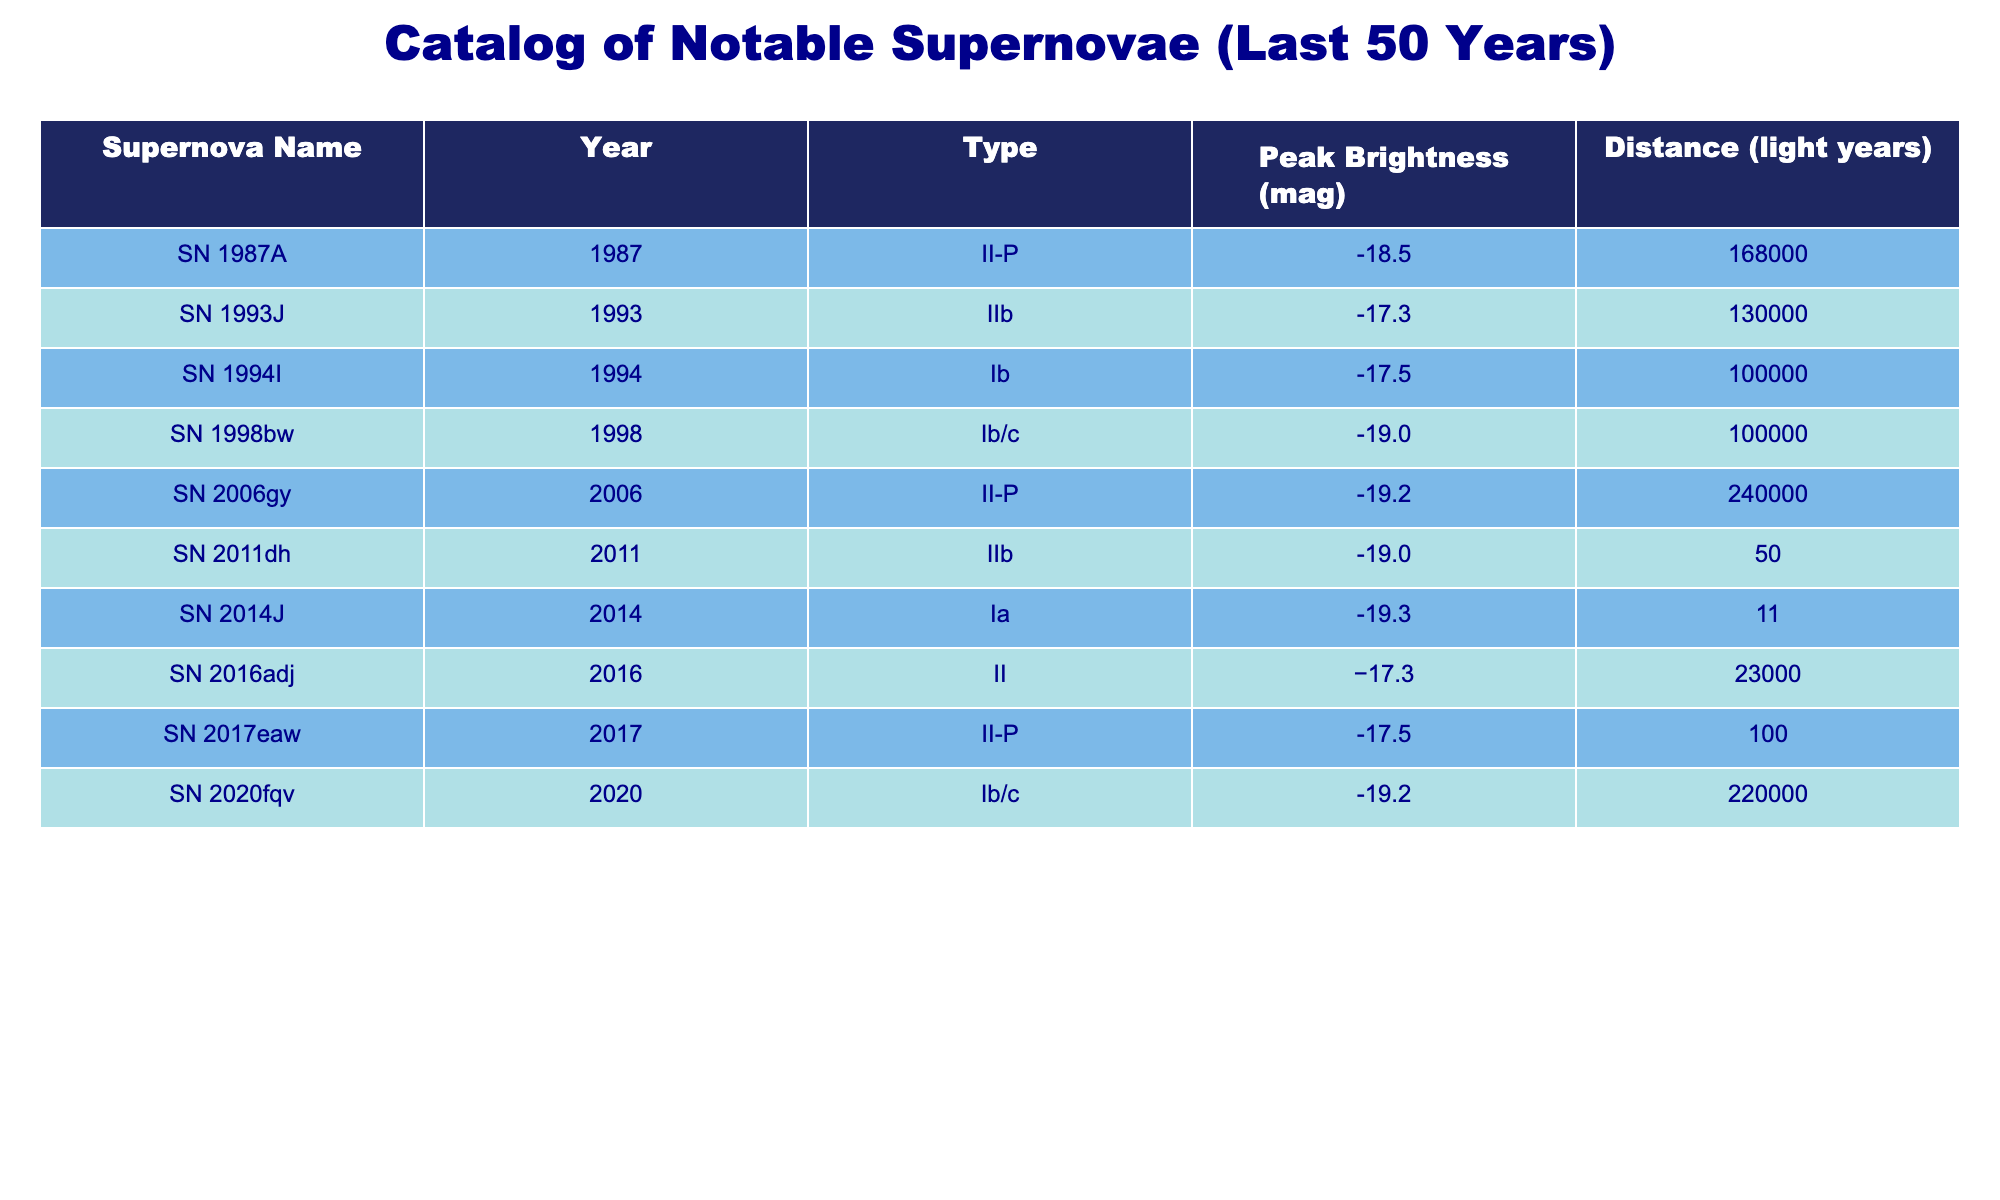What is the peak brightness of SN 1994I? The table lists the peak brightness values in the "Peak Brightness (mag)" column. For SN 1994I, the peak brightness value is directly presented as -17.5.
Answer: -17.5 What type of supernova is SN 2020fqv? The table provides a “Type” column where the classification of each supernova is mentioned. Looking at the row for SN 2020fqv, it is categorized as Ib/c.
Answer: Ib/c Which supernova has the highest peak brightness? To determine this, we need to look through the "Peak Brightness (mag)" values and identify the most negative (brightest) number. Comparing all values, SN 1998bw has the highest peak brightness at -19.0.
Answer: SN 1998bw How many supernovae have a peak brightness of -19 or brighter? We will count the supernova entries with a peak brightness less than or equal to -19. The relevant entries are SN 1987A, SN 1998bw, SN 2006gy, SN 2011dh, and SN 2014J. Thus, there are 4 supernovae in total.
Answer: 4 Is SN 2014J further away than SN 2011dh? We need to compare the distances listed for both supernovae in the "Distance (light years)" column. SN 2014J is at 11 light years while SN 2011dh is at 50 light years. Since 50 is greater than 11, SN 2014J is not further away.
Answer: No What is the average distance of the supernovae observed in this table? To find the average distance, we sum the distances from all entries, which are 168000 + 130000 + 100000 + 100000 + 240000 + 50 + 11 + 23000 + 100 + 220000 = 1008161 light years. Then, we divide this by the number of supernovae, which is 9. Therefore, the average distance is 1008161 / 9 ≈ 112..
Answer: Approximately 112,000 Which supernova is the nearest, and what is its distance? We will check the “Distance (light years)” column to find the smallest value. The nearest supernova is SN 2014J at a distance of 11 light years.
Answer: SN 2014J, 11 light years Are there any supernovae classified as II-P observed in the table? By searching the "Type" column for the II-P classification, we can see that SN 1987A and SN 2006gy are both classified as II-P. Thus, there are such supernovae in the table.
Answer: Yes Which supernova types are represented in the table? We will list the unique types found in the "Type" column. The unique entries are II-P, IIb, Ib, Ib/c, Ia, and II. These types include multiple classifications, showing diversity among the observed supernovae.
Answer: II-P, IIb, Ib, Ib/c, Ia, II 